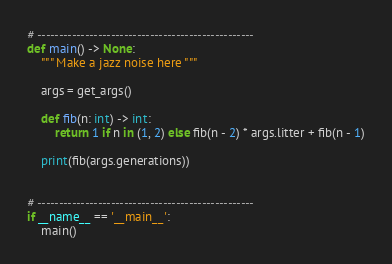<code> <loc_0><loc_0><loc_500><loc_500><_Python_># --------------------------------------------------
def main() -> None:
    """ Make a jazz noise here """

    args = get_args()

    def fib(n: int) -> int:
        return 1 if n in (1, 2) else fib(n - 2) * args.litter + fib(n - 1)

    print(fib(args.generations))


# --------------------------------------------------
if __name__ == '__main__':
    main()
</code> 